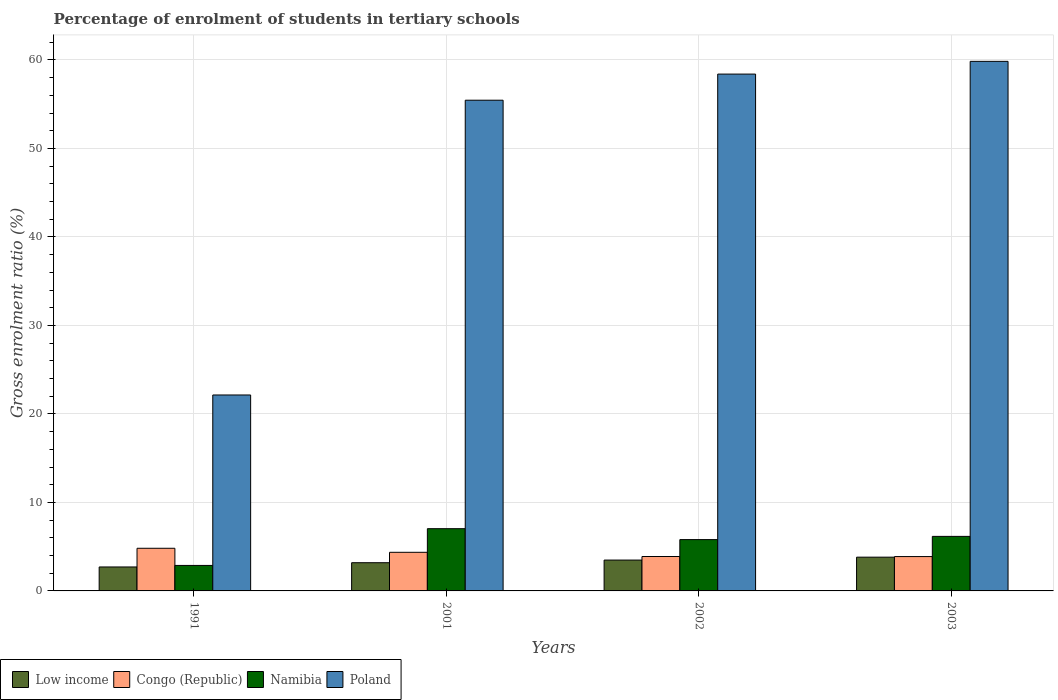How many different coloured bars are there?
Your answer should be very brief. 4. Are the number of bars on each tick of the X-axis equal?
Offer a terse response. Yes. How many bars are there on the 3rd tick from the right?
Ensure brevity in your answer.  4. What is the label of the 3rd group of bars from the left?
Give a very brief answer. 2002. In how many cases, is the number of bars for a given year not equal to the number of legend labels?
Keep it short and to the point. 0. What is the percentage of students enrolled in tertiary schools in Poland in 2001?
Provide a succinct answer. 55.45. Across all years, what is the maximum percentage of students enrolled in tertiary schools in Namibia?
Provide a succinct answer. 7.03. Across all years, what is the minimum percentage of students enrolled in tertiary schools in Namibia?
Ensure brevity in your answer.  2.88. In which year was the percentage of students enrolled in tertiary schools in Namibia minimum?
Offer a terse response. 1991. What is the total percentage of students enrolled in tertiary schools in Congo (Republic) in the graph?
Offer a very short reply. 16.95. What is the difference between the percentage of students enrolled in tertiary schools in Namibia in 1991 and that in 2003?
Offer a terse response. -3.28. What is the difference between the percentage of students enrolled in tertiary schools in Congo (Republic) in 2003 and the percentage of students enrolled in tertiary schools in Low income in 1991?
Provide a short and direct response. 1.17. What is the average percentage of students enrolled in tertiary schools in Poland per year?
Ensure brevity in your answer.  48.96. In the year 2002, what is the difference between the percentage of students enrolled in tertiary schools in Low income and percentage of students enrolled in tertiary schools in Poland?
Ensure brevity in your answer.  -54.91. What is the ratio of the percentage of students enrolled in tertiary schools in Low income in 1991 to that in 2001?
Your answer should be very brief. 0.85. Is the difference between the percentage of students enrolled in tertiary schools in Low income in 1991 and 2001 greater than the difference between the percentage of students enrolled in tertiary schools in Poland in 1991 and 2001?
Offer a very short reply. Yes. What is the difference between the highest and the second highest percentage of students enrolled in tertiary schools in Congo (Republic)?
Your answer should be compact. 0.46. What is the difference between the highest and the lowest percentage of students enrolled in tertiary schools in Poland?
Your answer should be compact. 37.7. In how many years, is the percentage of students enrolled in tertiary schools in Namibia greater than the average percentage of students enrolled in tertiary schools in Namibia taken over all years?
Provide a succinct answer. 3. Is the sum of the percentage of students enrolled in tertiary schools in Namibia in 2002 and 2003 greater than the maximum percentage of students enrolled in tertiary schools in Poland across all years?
Ensure brevity in your answer.  No. What does the 3rd bar from the left in 2002 represents?
Make the answer very short. Namibia. What does the 2nd bar from the right in 2003 represents?
Your response must be concise. Namibia. Is it the case that in every year, the sum of the percentage of students enrolled in tertiary schools in Low income and percentage of students enrolled in tertiary schools in Namibia is greater than the percentage of students enrolled in tertiary schools in Congo (Republic)?
Give a very brief answer. Yes. How many bars are there?
Provide a succinct answer. 16. Are the values on the major ticks of Y-axis written in scientific E-notation?
Your response must be concise. No. Where does the legend appear in the graph?
Your response must be concise. Bottom left. How many legend labels are there?
Your answer should be compact. 4. How are the legend labels stacked?
Your answer should be compact. Horizontal. What is the title of the graph?
Make the answer very short. Percentage of enrolment of students in tertiary schools. Does "Cabo Verde" appear as one of the legend labels in the graph?
Offer a terse response. No. What is the label or title of the X-axis?
Offer a terse response. Years. What is the label or title of the Y-axis?
Ensure brevity in your answer.  Gross enrolment ratio (%). What is the Gross enrolment ratio (%) of Low income in 1991?
Offer a terse response. 2.71. What is the Gross enrolment ratio (%) in Congo (Republic) in 1991?
Give a very brief answer. 4.82. What is the Gross enrolment ratio (%) of Namibia in 1991?
Give a very brief answer. 2.88. What is the Gross enrolment ratio (%) of Poland in 1991?
Provide a succinct answer. 22.14. What is the Gross enrolment ratio (%) in Low income in 2001?
Provide a short and direct response. 3.19. What is the Gross enrolment ratio (%) in Congo (Republic) in 2001?
Offer a very short reply. 4.36. What is the Gross enrolment ratio (%) of Namibia in 2001?
Give a very brief answer. 7.03. What is the Gross enrolment ratio (%) of Poland in 2001?
Ensure brevity in your answer.  55.45. What is the Gross enrolment ratio (%) of Low income in 2002?
Provide a succinct answer. 3.49. What is the Gross enrolment ratio (%) in Congo (Republic) in 2002?
Your answer should be compact. 3.89. What is the Gross enrolment ratio (%) in Namibia in 2002?
Make the answer very short. 5.8. What is the Gross enrolment ratio (%) in Poland in 2002?
Your answer should be very brief. 58.4. What is the Gross enrolment ratio (%) in Low income in 2003?
Offer a very short reply. 3.81. What is the Gross enrolment ratio (%) in Congo (Republic) in 2003?
Your answer should be compact. 3.88. What is the Gross enrolment ratio (%) in Namibia in 2003?
Keep it short and to the point. 6.16. What is the Gross enrolment ratio (%) in Poland in 2003?
Keep it short and to the point. 59.84. Across all years, what is the maximum Gross enrolment ratio (%) of Low income?
Ensure brevity in your answer.  3.81. Across all years, what is the maximum Gross enrolment ratio (%) in Congo (Republic)?
Ensure brevity in your answer.  4.82. Across all years, what is the maximum Gross enrolment ratio (%) of Namibia?
Your answer should be compact. 7.03. Across all years, what is the maximum Gross enrolment ratio (%) in Poland?
Provide a succinct answer. 59.84. Across all years, what is the minimum Gross enrolment ratio (%) of Low income?
Offer a very short reply. 2.71. Across all years, what is the minimum Gross enrolment ratio (%) of Congo (Republic)?
Offer a very short reply. 3.88. Across all years, what is the minimum Gross enrolment ratio (%) in Namibia?
Make the answer very short. 2.88. Across all years, what is the minimum Gross enrolment ratio (%) of Poland?
Offer a very short reply. 22.14. What is the total Gross enrolment ratio (%) in Low income in the graph?
Provide a short and direct response. 13.2. What is the total Gross enrolment ratio (%) of Congo (Republic) in the graph?
Offer a terse response. 16.95. What is the total Gross enrolment ratio (%) of Namibia in the graph?
Your response must be concise. 21.88. What is the total Gross enrolment ratio (%) in Poland in the graph?
Provide a succinct answer. 195.83. What is the difference between the Gross enrolment ratio (%) of Low income in 1991 and that in 2001?
Your response must be concise. -0.48. What is the difference between the Gross enrolment ratio (%) in Congo (Republic) in 1991 and that in 2001?
Your answer should be compact. 0.46. What is the difference between the Gross enrolment ratio (%) of Namibia in 1991 and that in 2001?
Your answer should be very brief. -4.15. What is the difference between the Gross enrolment ratio (%) of Poland in 1991 and that in 2001?
Your response must be concise. -33.31. What is the difference between the Gross enrolment ratio (%) in Low income in 1991 and that in 2002?
Keep it short and to the point. -0.78. What is the difference between the Gross enrolment ratio (%) of Congo (Republic) in 1991 and that in 2002?
Offer a terse response. 0.93. What is the difference between the Gross enrolment ratio (%) in Namibia in 1991 and that in 2002?
Offer a very short reply. -2.92. What is the difference between the Gross enrolment ratio (%) in Poland in 1991 and that in 2002?
Keep it short and to the point. -36.26. What is the difference between the Gross enrolment ratio (%) of Low income in 1991 and that in 2003?
Offer a terse response. -1.11. What is the difference between the Gross enrolment ratio (%) of Congo (Republic) in 1991 and that in 2003?
Your answer should be compact. 0.94. What is the difference between the Gross enrolment ratio (%) in Namibia in 1991 and that in 2003?
Provide a succinct answer. -3.28. What is the difference between the Gross enrolment ratio (%) in Poland in 1991 and that in 2003?
Make the answer very short. -37.7. What is the difference between the Gross enrolment ratio (%) of Low income in 2001 and that in 2002?
Ensure brevity in your answer.  -0.3. What is the difference between the Gross enrolment ratio (%) of Congo (Republic) in 2001 and that in 2002?
Keep it short and to the point. 0.47. What is the difference between the Gross enrolment ratio (%) of Namibia in 2001 and that in 2002?
Give a very brief answer. 1.23. What is the difference between the Gross enrolment ratio (%) in Poland in 2001 and that in 2002?
Your answer should be compact. -2.95. What is the difference between the Gross enrolment ratio (%) in Low income in 2001 and that in 2003?
Your answer should be compact. -0.63. What is the difference between the Gross enrolment ratio (%) of Congo (Republic) in 2001 and that in 2003?
Offer a very short reply. 0.48. What is the difference between the Gross enrolment ratio (%) of Namibia in 2001 and that in 2003?
Provide a succinct answer. 0.87. What is the difference between the Gross enrolment ratio (%) of Poland in 2001 and that in 2003?
Make the answer very short. -4.39. What is the difference between the Gross enrolment ratio (%) in Low income in 2002 and that in 2003?
Provide a succinct answer. -0.33. What is the difference between the Gross enrolment ratio (%) of Congo (Republic) in 2002 and that in 2003?
Make the answer very short. 0.01. What is the difference between the Gross enrolment ratio (%) in Namibia in 2002 and that in 2003?
Your answer should be compact. -0.36. What is the difference between the Gross enrolment ratio (%) in Poland in 2002 and that in 2003?
Provide a succinct answer. -1.44. What is the difference between the Gross enrolment ratio (%) in Low income in 1991 and the Gross enrolment ratio (%) in Congo (Republic) in 2001?
Keep it short and to the point. -1.66. What is the difference between the Gross enrolment ratio (%) of Low income in 1991 and the Gross enrolment ratio (%) of Namibia in 2001?
Make the answer very short. -4.32. What is the difference between the Gross enrolment ratio (%) of Low income in 1991 and the Gross enrolment ratio (%) of Poland in 2001?
Provide a succinct answer. -52.74. What is the difference between the Gross enrolment ratio (%) in Congo (Republic) in 1991 and the Gross enrolment ratio (%) in Namibia in 2001?
Give a very brief answer. -2.21. What is the difference between the Gross enrolment ratio (%) of Congo (Republic) in 1991 and the Gross enrolment ratio (%) of Poland in 2001?
Make the answer very short. -50.63. What is the difference between the Gross enrolment ratio (%) in Namibia in 1991 and the Gross enrolment ratio (%) in Poland in 2001?
Make the answer very short. -52.57. What is the difference between the Gross enrolment ratio (%) in Low income in 1991 and the Gross enrolment ratio (%) in Congo (Republic) in 2002?
Keep it short and to the point. -1.18. What is the difference between the Gross enrolment ratio (%) of Low income in 1991 and the Gross enrolment ratio (%) of Namibia in 2002?
Your response must be concise. -3.09. What is the difference between the Gross enrolment ratio (%) in Low income in 1991 and the Gross enrolment ratio (%) in Poland in 2002?
Make the answer very short. -55.69. What is the difference between the Gross enrolment ratio (%) of Congo (Republic) in 1991 and the Gross enrolment ratio (%) of Namibia in 2002?
Offer a terse response. -0.98. What is the difference between the Gross enrolment ratio (%) of Congo (Republic) in 1991 and the Gross enrolment ratio (%) of Poland in 2002?
Ensure brevity in your answer.  -53.58. What is the difference between the Gross enrolment ratio (%) of Namibia in 1991 and the Gross enrolment ratio (%) of Poland in 2002?
Your answer should be very brief. -55.52. What is the difference between the Gross enrolment ratio (%) of Low income in 1991 and the Gross enrolment ratio (%) of Congo (Republic) in 2003?
Ensure brevity in your answer.  -1.17. What is the difference between the Gross enrolment ratio (%) in Low income in 1991 and the Gross enrolment ratio (%) in Namibia in 2003?
Ensure brevity in your answer.  -3.45. What is the difference between the Gross enrolment ratio (%) in Low income in 1991 and the Gross enrolment ratio (%) in Poland in 2003?
Keep it short and to the point. -57.13. What is the difference between the Gross enrolment ratio (%) in Congo (Republic) in 1991 and the Gross enrolment ratio (%) in Namibia in 2003?
Provide a succinct answer. -1.34. What is the difference between the Gross enrolment ratio (%) in Congo (Republic) in 1991 and the Gross enrolment ratio (%) in Poland in 2003?
Your response must be concise. -55.02. What is the difference between the Gross enrolment ratio (%) of Namibia in 1991 and the Gross enrolment ratio (%) of Poland in 2003?
Make the answer very short. -56.96. What is the difference between the Gross enrolment ratio (%) of Low income in 2001 and the Gross enrolment ratio (%) of Congo (Republic) in 2002?
Give a very brief answer. -0.7. What is the difference between the Gross enrolment ratio (%) of Low income in 2001 and the Gross enrolment ratio (%) of Namibia in 2002?
Your response must be concise. -2.61. What is the difference between the Gross enrolment ratio (%) of Low income in 2001 and the Gross enrolment ratio (%) of Poland in 2002?
Keep it short and to the point. -55.21. What is the difference between the Gross enrolment ratio (%) of Congo (Republic) in 2001 and the Gross enrolment ratio (%) of Namibia in 2002?
Your response must be concise. -1.44. What is the difference between the Gross enrolment ratio (%) of Congo (Republic) in 2001 and the Gross enrolment ratio (%) of Poland in 2002?
Provide a succinct answer. -54.04. What is the difference between the Gross enrolment ratio (%) in Namibia in 2001 and the Gross enrolment ratio (%) in Poland in 2002?
Provide a short and direct response. -51.37. What is the difference between the Gross enrolment ratio (%) of Low income in 2001 and the Gross enrolment ratio (%) of Congo (Republic) in 2003?
Your answer should be compact. -0.69. What is the difference between the Gross enrolment ratio (%) of Low income in 2001 and the Gross enrolment ratio (%) of Namibia in 2003?
Provide a short and direct response. -2.97. What is the difference between the Gross enrolment ratio (%) in Low income in 2001 and the Gross enrolment ratio (%) in Poland in 2003?
Your answer should be compact. -56.65. What is the difference between the Gross enrolment ratio (%) of Congo (Republic) in 2001 and the Gross enrolment ratio (%) of Namibia in 2003?
Give a very brief answer. -1.8. What is the difference between the Gross enrolment ratio (%) of Congo (Republic) in 2001 and the Gross enrolment ratio (%) of Poland in 2003?
Your response must be concise. -55.48. What is the difference between the Gross enrolment ratio (%) of Namibia in 2001 and the Gross enrolment ratio (%) of Poland in 2003?
Keep it short and to the point. -52.81. What is the difference between the Gross enrolment ratio (%) in Low income in 2002 and the Gross enrolment ratio (%) in Congo (Republic) in 2003?
Your answer should be compact. -0.39. What is the difference between the Gross enrolment ratio (%) of Low income in 2002 and the Gross enrolment ratio (%) of Namibia in 2003?
Offer a terse response. -2.68. What is the difference between the Gross enrolment ratio (%) of Low income in 2002 and the Gross enrolment ratio (%) of Poland in 2003?
Make the answer very short. -56.35. What is the difference between the Gross enrolment ratio (%) in Congo (Republic) in 2002 and the Gross enrolment ratio (%) in Namibia in 2003?
Your answer should be very brief. -2.27. What is the difference between the Gross enrolment ratio (%) in Congo (Republic) in 2002 and the Gross enrolment ratio (%) in Poland in 2003?
Make the answer very short. -55.95. What is the difference between the Gross enrolment ratio (%) of Namibia in 2002 and the Gross enrolment ratio (%) of Poland in 2003?
Ensure brevity in your answer.  -54.04. What is the average Gross enrolment ratio (%) of Low income per year?
Keep it short and to the point. 3.3. What is the average Gross enrolment ratio (%) of Congo (Republic) per year?
Make the answer very short. 4.24. What is the average Gross enrolment ratio (%) of Namibia per year?
Give a very brief answer. 5.47. What is the average Gross enrolment ratio (%) in Poland per year?
Your answer should be very brief. 48.96. In the year 1991, what is the difference between the Gross enrolment ratio (%) in Low income and Gross enrolment ratio (%) in Congo (Republic)?
Make the answer very short. -2.11. In the year 1991, what is the difference between the Gross enrolment ratio (%) in Low income and Gross enrolment ratio (%) in Namibia?
Your response must be concise. -0.17. In the year 1991, what is the difference between the Gross enrolment ratio (%) of Low income and Gross enrolment ratio (%) of Poland?
Offer a very short reply. -19.43. In the year 1991, what is the difference between the Gross enrolment ratio (%) of Congo (Republic) and Gross enrolment ratio (%) of Namibia?
Your response must be concise. 1.94. In the year 1991, what is the difference between the Gross enrolment ratio (%) of Congo (Republic) and Gross enrolment ratio (%) of Poland?
Offer a terse response. -17.32. In the year 1991, what is the difference between the Gross enrolment ratio (%) in Namibia and Gross enrolment ratio (%) in Poland?
Provide a short and direct response. -19.26. In the year 2001, what is the difference between the Gross enrolment ratio (%) of Low income and Gross enrolment ratio (%) of Congo (Republic)?
Offer a terse response. -1.18. In the year 2001, what is the difference between the Gross enrolment ratio (%) in Low income and Gross enrolment ratio (%) in Namibia?
Your answer should be very brief. -3.84. In the year 2001, what is the difference between the Gross enrolment ratio (%) in Low income and Gross enrolment ratio (%) in Poland?
Your answer should be compact. -52.26. In the year 2001, what is the difference between the Gross enrolment ratio (%) in Congo (Republic) and Gross enrolment ratio (%) in Namibia?
Your response must be concise. -2.67. In the year 2001, what is the difference between the Gross enrolment ratio (%) of Congo (Republic) and Gross enrolment ratio (%) of Poland?
Give a very brief answer. -51.09. In the year 2001, what is the difference between the Gross enrolment ratio (%) in Namibia and Gross enrolment ratio (%) in Poland?
Give a very brief answer. -48.42. In the year 2002, what is the difference between the Gross enrolment ratio (%) of Low income and Gross enrolment ratio (%) of Congo (Republic)?
Your response must be concise. -0.4. In the year 2002, what is the difference between the Gross enrolment ratio (%) of Low income and Gross enrolment ratio (%) of Namibia?
Offer a terse response. -2.31. In the year 2002, what is the difference between the Gross enrolment ratio (%) in Low income and Gross enrolment ratio (%) in Poland?
Provide a short and direct response. -54.91. In the year 2002, what is the difference between the Gross enrolment ratio (%) of Congo (Republic) and Gross enrolment ratio (%) of Namibia?
Make the answer very short. -1.91. In the year 2002, what is the difference between the Gross enrolment ratio (%) of Congo (Republic) and Gross enrolment ratio (%) of Poland?
Provide a short and direct response. -54.51. In the year 2002, what is the difference between the Gross enrolment ratio (%) of Namibia and Gross enrolment ratio (%) of Poland?
Make the answer very short. -52.6. In the year 2003, what is the difference between the Gross enrolment ratio (%) in Low income and Gross enrolment ratio (%) in Congo (Republic)?
Provide a short and direct response. -0.07. In the year 2003, what is the difference between the Gross enrolment ratio (%) of Low income and Gross enrolment ratio (%) of Namibia?
Your answer should be compact. -2.35. In the year 2003, what is the difference between the Gross enrolment ratio (%) of Low income and Gross enrolment ratio (%) of Poland?
Offer a terse response. -56.02. In the year 2003, what is the difference between the Gross enrolment ratio (%) in Congo (Republic) and Gross enrolment ratio (%) in Namibia?
Keep it short and to the point. -2.28. In the year 2003, what is the difference between the Gross enrolment ratio (%) in Congo (Republic) and Gross enrolment ratio (%) in Poland?
Provide a short and direct response. -55.96. In the year 2003, what is the difference between the Gross enrolment ratio (%) of Namibia and Gross enrolment ratio (%) of Poland?
Your response must be concise. -53.68. What is the ratio of the Gross enrolment ratio (%) of Low income in 1991 to that in 2001?
Provide a short and direct response. 0.85. What is the ratio of the Gross enrolment ratio (%) in Congo (Republic) in 1991 to that in 2001?
Your response must be concise. 1.1. What is the ratio of the Gross enrolment ratio (%) in Namibia in 1991 to that in 2001?
Offer a very short reply. 0.41. What is the ratio of the Gross enrolment ratio (%) of Poland in 1991 to that in 2001?
Give a very brief answer. 0.4. What is the ratio of the Gross enrolment ratio (%) in Low income in 1991 to that in 2002?
Ensure brevity in your answer.  0.78. What is the ratio of the Gross enrolment ratio (%) in Congo (Republic) in 1991 to that in 2002?
Give a very brief answer. 1.24. What is the ratio of the Gross enrolment ratio (%) of Namibia in 1991 to that in 2002?
Your answer should be very brief. 0.5. What is the ratio of the Gross enrolment ratio (%) of Poland in 1991 to that in 2002?
Offer a terse response. 0.38. What is the ratio of the Gross enrolment ratio (%) in Low income in 1991 to that in 2003?
Provide a short and direct response. 0.71. What is the ratio of the Gross enrolment ratio (%) in Congo (Republic) in 1991 to that in 2003?
Your response must be concise. 1.24. What is the ratio of the Gross enrolment ratio (%) of Namibia in 1991 to that in 2003?
Ensure brevity in your answer.  0.47. What is the ratio of the Gross enrolment ratio (%) in Poland in 1991 to that in 2003?
Your answer should be compact. 0.37. What is the ratio of the Gross enrolment ratio (%) of Low income in 2001 to that in 2002?
Provide a succinct answer. 0.91. What is the ratio of the Gross enrolment ratio (%) of Congo (Republic) in 2001 to that in 2002?
Keep it short and to the point. 1.12. What is the ratio of the Gross enrolment ratio (%) of Namibia in 2001 to that in 2002?
Your answer should be very brief. 1.21. What is the ratio of the Gross enrolment ratio (%) of Poland in 2001 to that in 2002?
Give a very brief answer. 0.95. What is the ratio of the Gross enrolment ratio (%) of Low income in 2001 to that in 2003?
Ensure brevity in your answer.  0.84. What is the ratio of the Gross enrolment ratio (%) in Congo (Republic) in 2001 to that in 2003?
Give a very brief answer. 1.12. What is the ratio of the Gross enrolment ratio (%) in Namibia in 2001 to that in 2003?
Make the answer very short. 1.14. What is the ratio of the Gross enrolment ratio (%) of Poland in 2001 to that in 2003?
Give a very brief answer. 0.93. What is the ratio of the Gross enrolment ratio (%) in Low income in 2002 to that in 2003?
Your response must be concise. 0.91. What is the ratio of the Gross enrolment ratio (%) in Congo (Republic) in 2002 to that in 2003?
Offer a terse response. 1. What is the ratio of the Gross enrolment ratio (%) of Namibia in 2002 to that in 2003?
Give a very brief answer. 0.94. What is the difference between the highest and the second highest Gross enrolment ratio (%) in Low income?
Keep it short and to the point. 0.33. What is the difference between the highest and the second highest Gross enrolment ratio (%) in Congo (Republic)?
Give a very brief answer. 0.46. What is the difference between the highest and the second highest Gross enrolment ratio (%) of Namibia?
Make the answer very short. 0.87. What is the difference between the highest and the second highest Gross enrolment ratio (%) in Poland?
Keep it short and to the point. 1.44. What is the difference between the highest and the lowest Gross enrolment ratio (%) in Low income?
Your response must be concise. 1.11. What is the difference between the highest and the lowest Gross enrolment ratio (%) in Congo (Republic)?
Give a very brief answer. 0.94. What is the difference between the highest and the lowest Gross enrolment ratio (%) of Namibia?
Provide a succinct answer. 4.15. What is the difference between the highest and the lowest Gross enrolment ratio (%) of Poland?
Offer a very short reply. 37.7. 